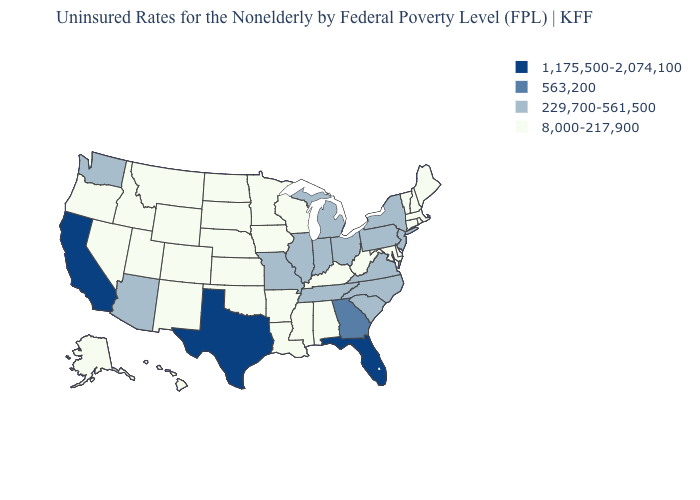What is the lowest value in states that border Indiana?
Keep it brief. 8,000-217,900. What is the value of California?
Quick response, please. 1,175,500-2,074,100. Name the states that have a value in the range 229,700-561,500?
Give a very brief answer. Arizona, Illinois, Indiana, Michigan, Missouri, New Jersey, New York, North Carolina, Ohio, Pennsylvania, South Carolina, Tennessee, Virginia, Washington. What is the value of North Dakota?
Concise answer only. 8,000-217,900. Does Alaska have the lowest value in the West?
Give a very brief answer. Yes. Name the states that have a value in the range 8,000-217,900?
Answer briefly. Alabama, Alaska, Arkansas, Colorado, Connecticut, Delaware, Hawaii, Idaho, Iowa, Kansas, Kentucky, Louisiana, Maine, Maryland, Massachusetts, Minnesota, Mississippi, Montana, Nebraska, Nevada, New Hampshire, New Mexico, North Dakota, Oklahoma, Oregon, Rhode Island, South Dakota, Utah, Vermont, West Virginia, Wisconsin, Wyoming. What is the highest value in the USA?
Concise answer only. 1,175,500-2,074,100. What is the lowest value in the MidWest?
Quick response, please. 8,000-217,900. Does Georgia have the lowest value in the South?
Give a very brief answer. No. What is the lowest value in the Northeast?
Short answer required. 8,000-217,900. What is the highest value in states that border Montana?
Short answer required. 8,000-217,900. How many symbols are there in the legend?
Give a very brief answer. 4. How many symbols are there in the legend?
Be succinct. 4. How many symbols are there in the legend?
Concise answer only. 4. Which states have the lowest value in the West?
Quick response, please. Alaska, Colorado, Hawaii, Idaho, Montana, Nevada, New Mexico, Oregon, Utah, Wyoming. 